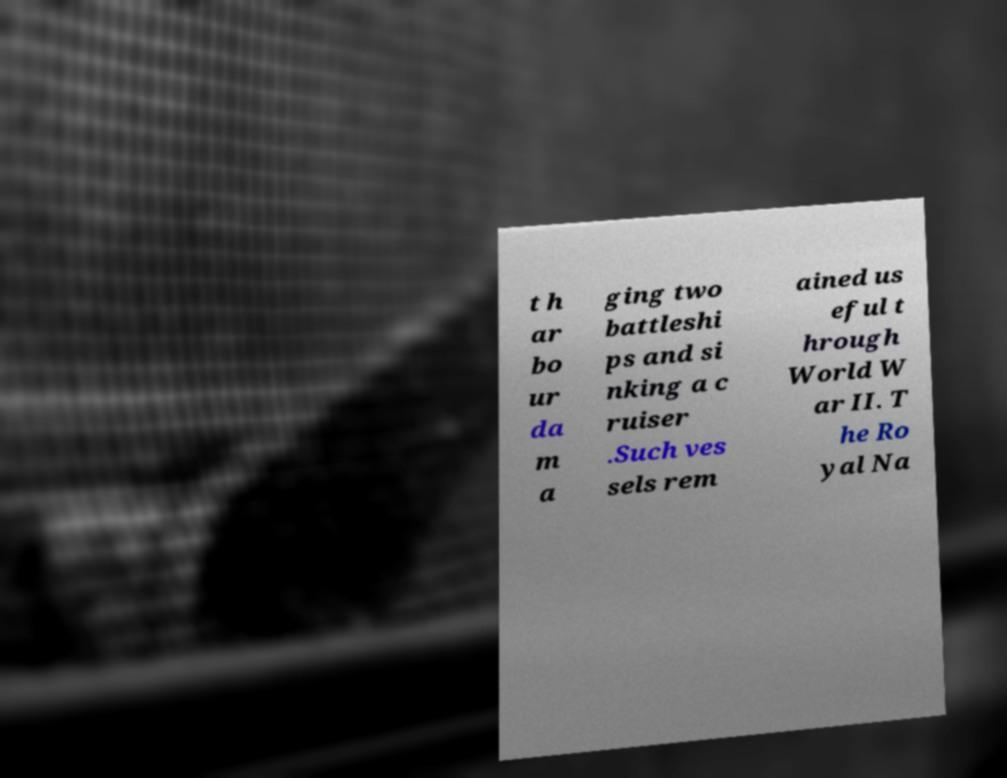Can you accurately transcribe the text from the provided image for me? t h ar bo ur da m a ging two battleshi ps and si nking a c ruiser .Such ves sels rem ained us eful t hrough World W ar II. T he Ro yal Na 